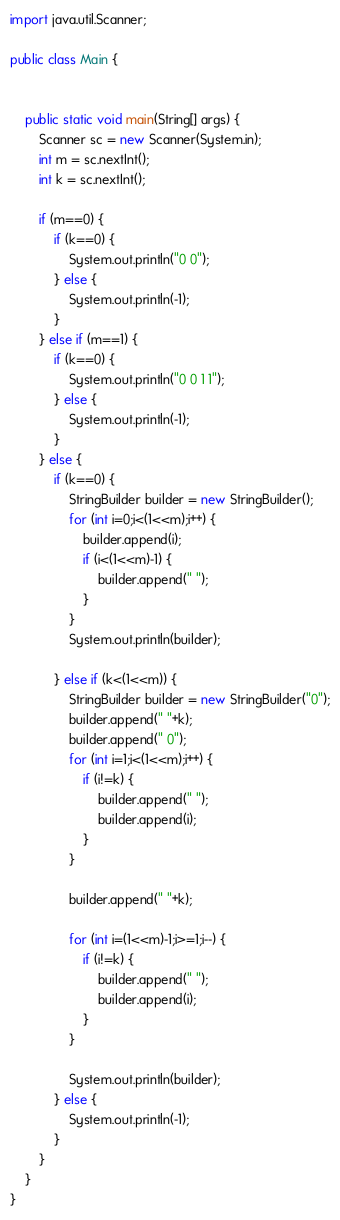Convert code to text. <code><loc_0><loc_0><loc_500><loc_500><_Java_>
import java.util.Scanner;

public class Main {

	
	public static void main(String[] args) {
		Scanner sc = new Scanner(System.in);
		int m = sc.nextInt();
		int k = sc.nextInt();
	
		if (m==0) {
			if (k==0) {
				System.out.println("0 0");
			} else {
				System.out.println(-1);
			}
		} else if (m==1) {
			if (k==0) {
				System.out.println("0 0 1 1");
			} else {
				System.out.println(-1);
			}
		} else {
			if (k==0) {
				StringBuilder builder = new StringBuilder();
				for (int i=0;i<(1<<m);i++) {
					builder.append(i);
					if (i<(1<<m)-1) {
						builder.append(" ");
					}
				}
				System.out.println(builder);
				
			} else if (k<(1<<m)) {
				StringBuilder builder = new StringBuilder("0");
				builder.append(" "+k);
				builder.append(" 0");
				for (int i=1;i<(1<<m);i++) {
					if (i!=k) {
						builder.append(" ");
						builder.append(i);
					}
				}
				
				builder.append(" "+k);
				
				for (int i=(1<<m)-1;i>=1;i--) {
					if (i!=k) {
						builder.append(" ");
						builder.append(i);
					}
				}
				
				System.out.println(builder);
			} else {
				System.out.println(-1);
			}
		}
	}
}
</code> 